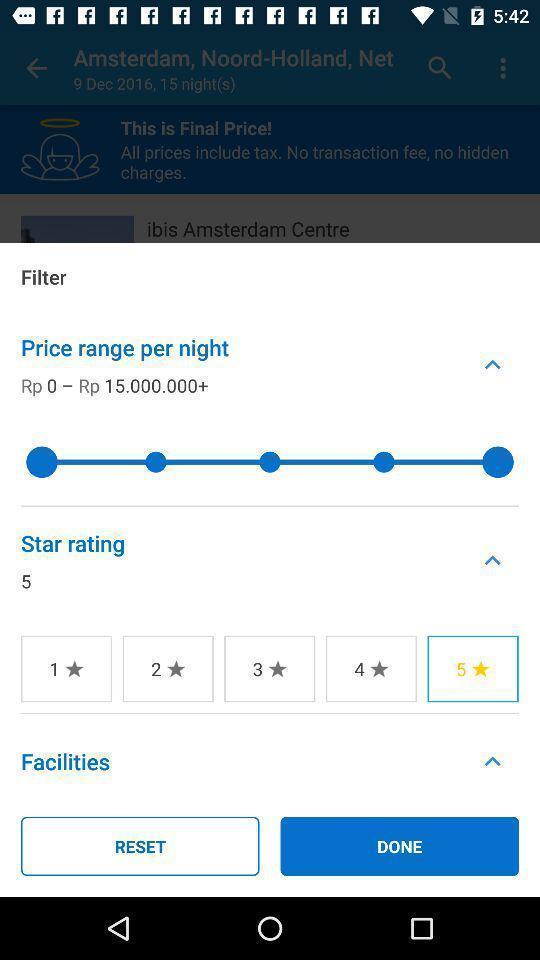Summarize the information in this screenshot. Screen showing different price filter ranges. 